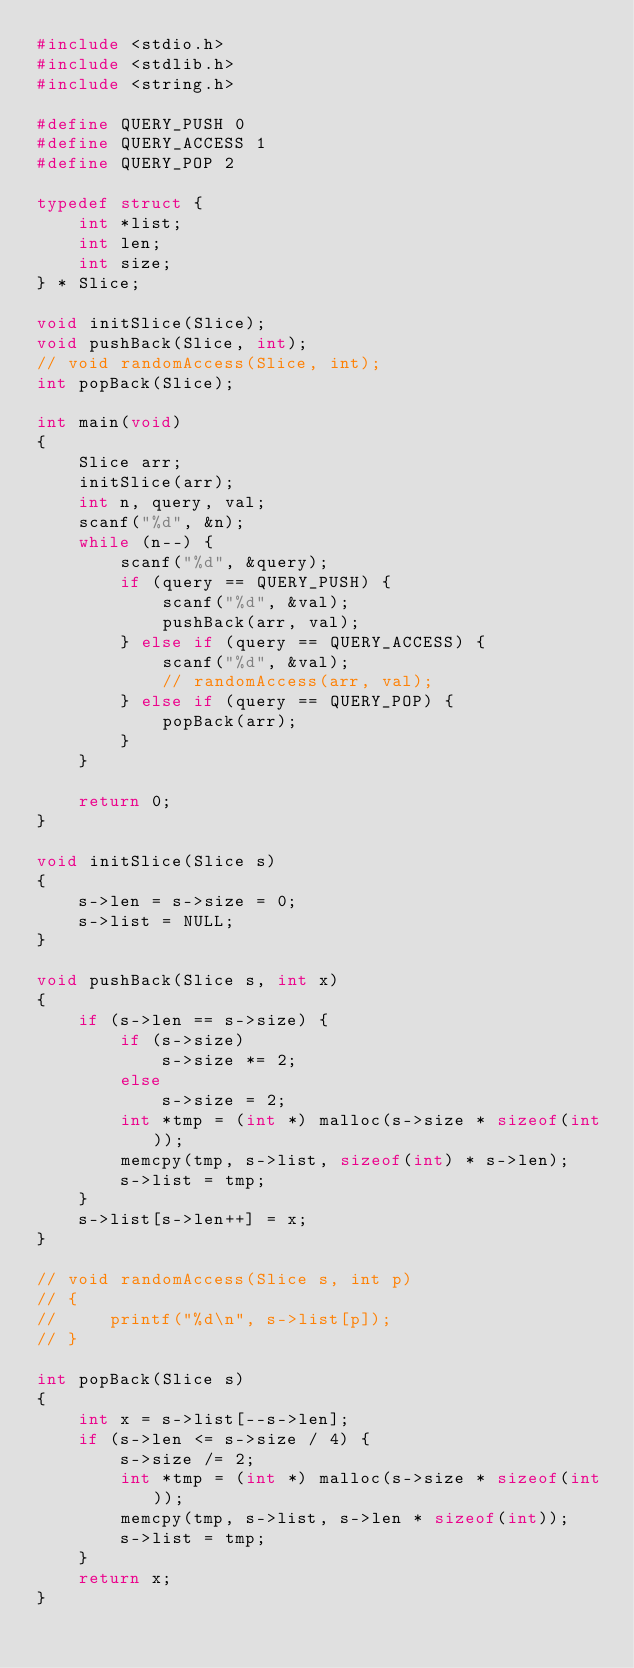Convert code to text. <code><loc_0><loc_0><loc_500><loc_500><_C_>#include <stdio.h>
#include <stdlib.h>
#include <string.h>

#define QUERY_PUSH 0
#define QUERY_ACCESS 1
#define QUERY_POP 2

typedef struct {
    int *list;
    int len;
    int size;
} * Slice;

void initSlice(Slice);
void pushBack(Slice, int);
// void randomAccess(Slice, int);
int popBack(Slice);

int main(void)
{
    Slice arr;
    initSlice(arr);
    int n, query, val;
    scanf("%d", &n);
    while (n--) {
        scanf("%d", &query);
        if (query == QUERY_PUSH) {
            scanf("%d", &val);
            pushBack(arr, val);
        } else if (query == QUERY_ACCESS) {
            scanf("%d", &val);
            // randomAccess(arr, val);
        } else if (query == QUERY_POP) {
            popBack(arr);
        }
    }

    return 0;
}

void initSlice(Slice s)
{
    s->len = s->size = 0;
    s->list = NULL;
}

void pushBack(Slice s, int x)
{
    if (s->len == s->size) {
        if (s->size)
            s->size *= 2;
        else
            s->size = 2;
        int *tmp = (int *) malloc(s->size * sizeof(int));
        memcpy(tmp, s->list, sizeof(int) * s->len);
        s->list = tmp;
    }
    s->list[s->len++] = x;
}

// void randomAccess(Slice s, int p)
// {
//     printf("%d\n", s->list[p]);
// }

int popBack(Slice s)
{
    int x = s->list[--s->len];
    if (s->len <= s->size / 4) {
        s->size /= 2;
        int *tmp = (int *) malloc(s->size * sizeof(int));
        memcpy(tmp, s->list, s->len * sizeof(int));
        s->list = tmp;
    }
    return x;
}
</code> 